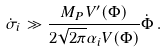<formula> <loc_0><loc_0><loc_500><loc_500>\dot { \sigma } _ { i } \gg \frac { M _ { P } V ^ { \prime } ( \Phi ) } { 2 \sqrt { 2 \pi } \alpha _ { i } V ( \Phi ) } \dot { \Phi } \, .</formula> 